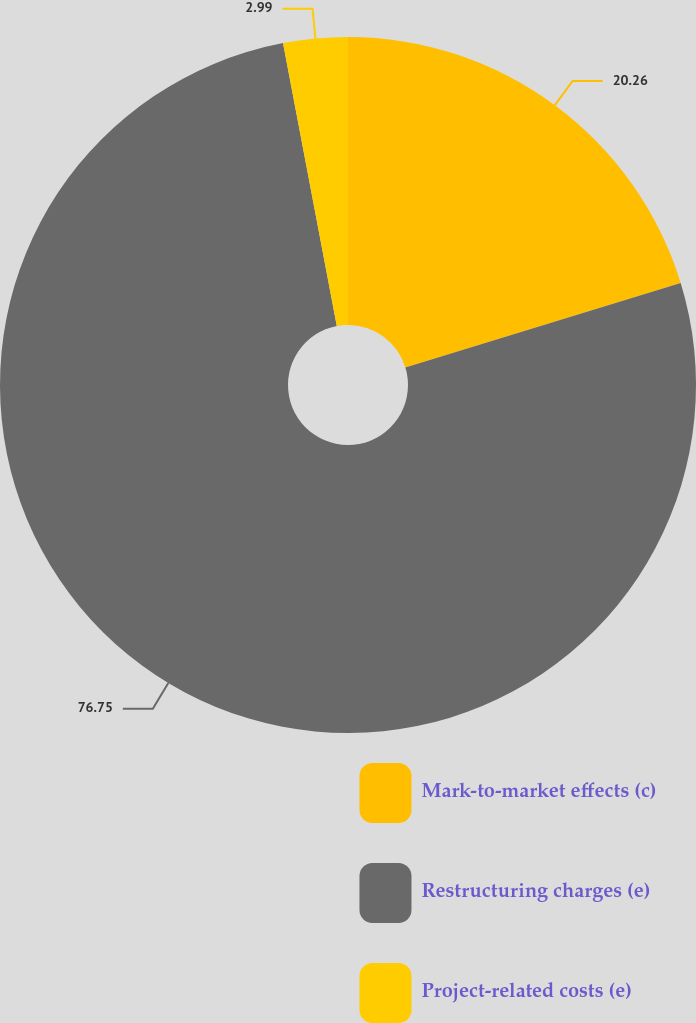Convert chart. <chart><loc_0><loc_0><loc_500><loc_500><pie_chart><fcel>Mark-to-market effects (c)<fcel>Restructuring charges (e)<fcel>Project-related costs (e)<nl><fcel>20.26%<fcel>76.75%<fcel>2.99%<nl></chart> 